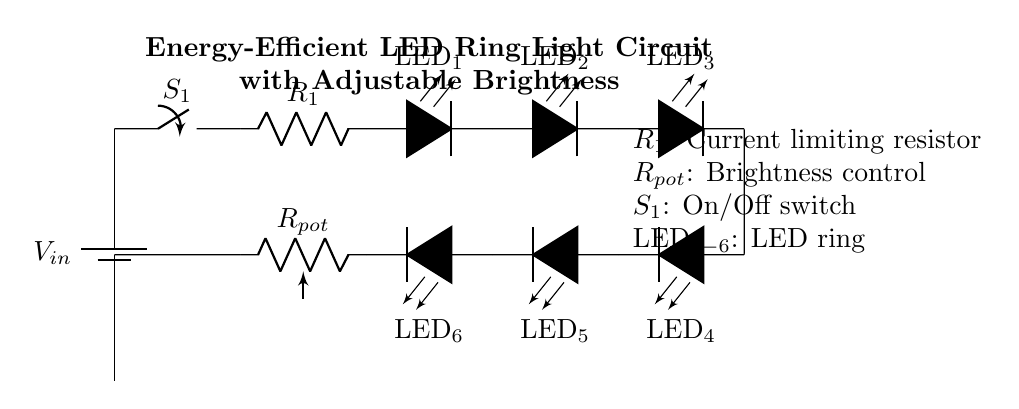What type of switch is used in this circuit? The circuit uses a mechanical switch, indicated by S1, which connects or disconnects the power supply to the rest of the components.
Answer: Mechanical switch How many LEDs are there in the ring light? The diagram shows a total of six LEDs arranged in a ring format, denoted as LED1 to LED6.
Answer: Six What is the function of the current limiting resistor? The current limiting resistor, labeled R1, is used to restrict the current flowing through the LEDs to prevent them from burning out or being damaged.
Answer: Current limiter What does the potentiometer control in this circuit? The potentiometer, labeled Rpot, adjusts the brightness of the LED ring by varying the resistance and, consequently, the current flowing through the LEDs.
Answer: Brightness What is the significance of the ground connection in this circuit? The ground connection serves as a common return path for the current, helping to stabilize the circuit and prevent potential safety issues.
Answer: Stabilization What will happen if R1 is too low in value? If R1 is too low, the current through the LEDs may exceed their maximum ratings, causing them to overheat and possibly burn out.
Answer: Overheating 